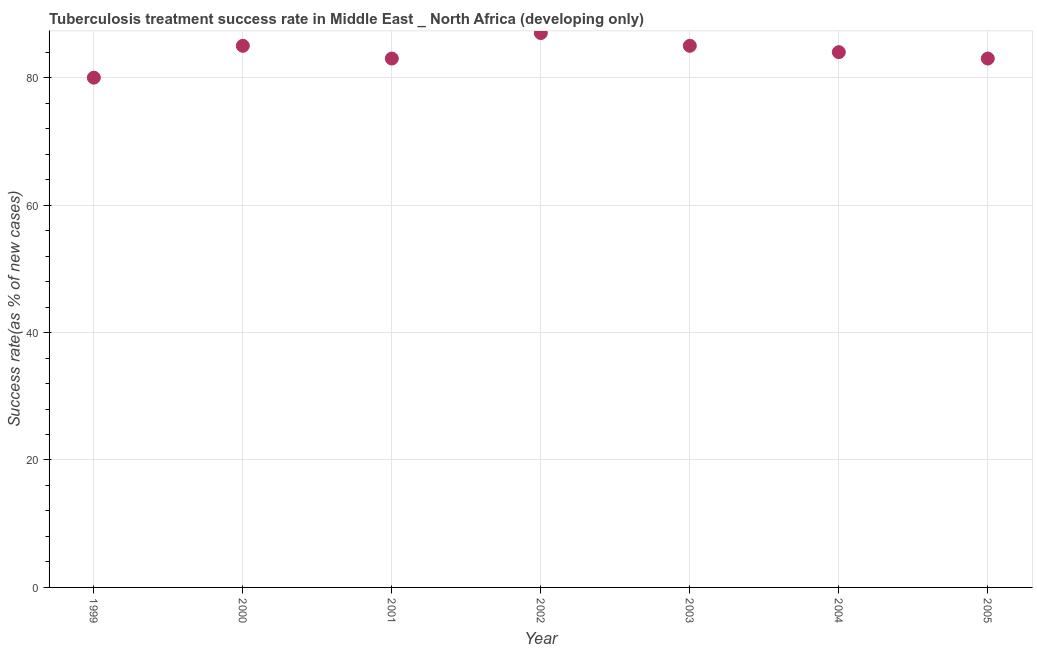What is the tuberculosis treatment success rate in 2005?
Your answer should be compact. 83. Across all years, what is the maximum tuberculosis treatment success rate?
Keep it short and to the point. 87. Across all years, what is the minimum tuberculosis treatment success rate?
Make the answer very short. 80. What is the sum of the tuberculosis treatment success rate?
Offer a very short reply. 587. What is the difference between the tuberculosis treatment success rate in 2000 and 2004?
Your answer should be compact. 1. What is the average tuberculosis treatment success rate per year?
Give a very brief answer. 83.86. In how many years, is the tuberculosis treatment success rate greater than 44 %?
Your answer should be very brief. 7. Do a majority of the years between 2001 and 2004 (inclusive) have tuberculosis treatment success rate greater than 64 %?
Provide a short and direct response. Yes. What is the ratio of the tuberculosis treatment success rate in 2002 to that in 2005?
Your answer should be compact. 1.05. Is the sum of the tuberculosis treatment success rate in 2002 and 2004 greater than the maximum tuberculosis treatment success rate across all years?
Your answer should be very brief. Yes. What is the difference between the highest and the lowest tuberculosis treatment success rate?
Offer a very short reply. 7. In how many years, is the tuberculosis treatment success rate greater than the average tuberculosis treatment success rate taken over all years?
Offer a very short reply. 4. Does the tuberculosis treatment success rate monotonically increase over the years?
Provide a succinct answer. No. What is the difference between two consecutive major ticks on the Y-axis?
Your answer should be compact. 20. Are the values on the major ticks of Y-axis written in scientific E-notation?
Your answer should be compact. No. Does the graph contain grids?
Offer a very short reply. Yes. What is the title of the graph?
Provide a succinct answer. Tuberculosis treatment success rate in Middle East _ North Africa (developing only). What is the label or title of the X-axis?
Provide a short and direct response. Year. What is the label or title of the Y-axis?
Keep it short and to the point. Success rate(as % of new cases). What is the Success rate(as % of new cases) in 2001?
Make the answer very short. 83. What is the Success rate(as % of new cases) in 2003?
Offer a very short reply. 85. What is the difference between the Success rate(as % of new cases) in 1999 and 2002?
Provide a short and direct response. -7. What is the difference between the Success rate(as % of new cases) in 1999 and 2004?
Your answer should be compact. -4. What is the difference between the Success rate(as % of new cases) in 1999 and 2005?
Your answer should be compact. -3. What is the difference between the Success rate(as % of new cases) in 2000 and 2002?
Keep it short and to the point. -2. What is the difference between the Success rate(as % of new cases) in 2000 and 2004?
Your response must be concise. 1. What is the difference between the Success rate(as % of new cases) in 2000 and 2005?
Your answer should be compact. 2. What is the difference between the Success rate(as % of new cases) in 2001 and 2002?
Your answer should be very brief. -4. What is the difference between the Success rate(as % of new cases) in 2002 and 2005?
Your answer should be very brief. 4. What is the difference between the Success rate(as % of new cases) in 2003 and 2004?
Ensure brevity in your answer.  1. What is the ratio of the Success rate(as % of new cases) in 1999 to that in 2000?
Give a very brief answer. 0.94. What is the ratio of the Success rate(as % of new cases) in 1999 to that in 2001?
Offer a very short reply. 0.96. What is the ratio of the Success rate(as % of new cases) in 1999 to that in 2003?
Offer a terse response. 0.94. What is the ratio of the Success rate(as % of new cases) in 2000 to that in 2002?
Provide a succinct answer. 0.98. What is the ratio of the Success rate(as % of new cases) in 2000 to that in 2005?
Your response must be concise. 1.02. What is the ratio of the Success rate(as % of new cases) in 2001 to that in 2002?
Your response must be concise. 0.95. What is the ratio of the Success rate(as % of new cases) in 2001 to that in 2005?
Provide a short and direct response. 1. What is the ratio of the Success rate(as % of new cases) in 2002 to that in 2003?
Your answer should be compact. 1.02. What is the ratio of the Success rate(as % of new cases) in 2002 to that in 2004?
Keep it short and to the point. 1.04. What is the ratio of the Success rate(as % of new cases) in 2002 to that in 2005?
Provide a succinct answer. 1.05. 